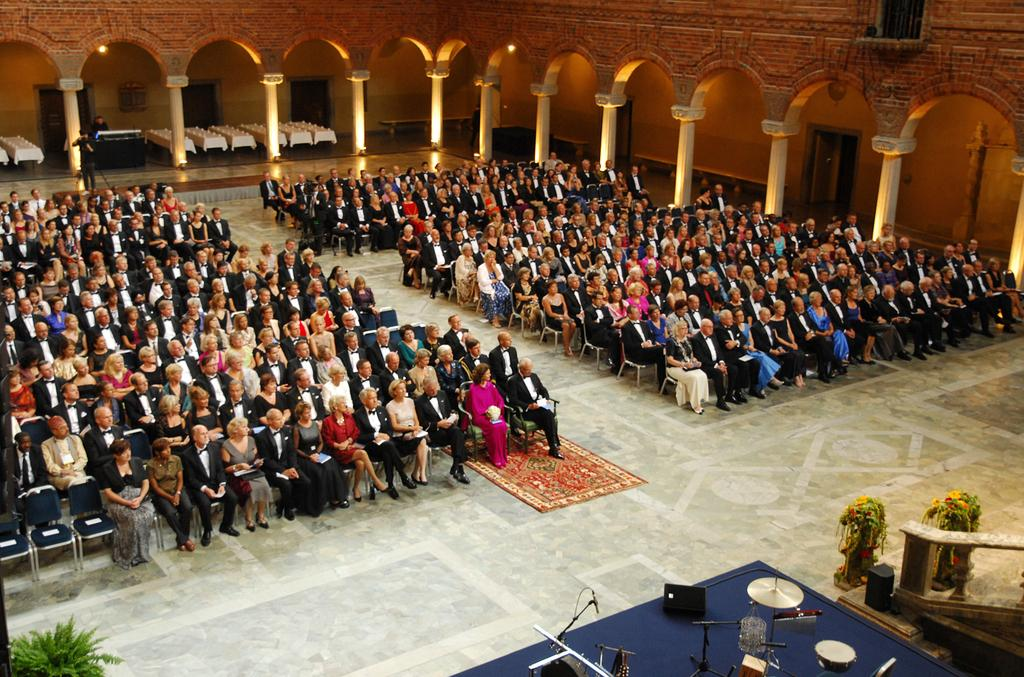What are the people in the image doing? There is a group of people sitting on chairs in the image. What can be seen around the group of people? There are pillars around the group of people. What musical instruments and equipment are visible in the image? There are drums and a mic on the right side in the image. What type of vegetation is present in the image? There is a plant on the left side in the image. How many cherries are on the plant in the image? There are no cherries present in the image; it features a plant without any visible fruit. What type of brush is being used by the person in the image? There is no person using a brush in the image; it only shows a group of people sitting on chairs, pillars, drums, a mic, and a plant. 